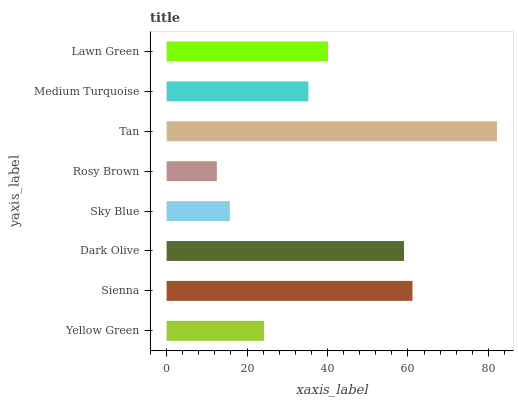Is Rosy Brown the minimum?
Answer yes or no. Yes. Is Tan the maximum?
Answer yes or no. Yes. Is Sienna the minimum?
Answer yes or no. No. Is Sienna the maximum?
Answer yes or no. No. Is Sienna greater than Yellow Green?
Answer yes or no. Yes. Is Yellow Green less than Sienna?
Answer yes or no. Yes. Is Yellow Green greater than Sienna?
Answer yes or no. No. Is Sienna less than Yellow Green?
Answer yes or no. No. Is Lawn Green the high median?
Answer yes or no. Yes. Is Medium Turquoise the low median?
Answer yes or no. Yes. Is Yellow Green the high median?
Answer yes or no. No. Is Sienna the low median?
Answer yes or no. No. 